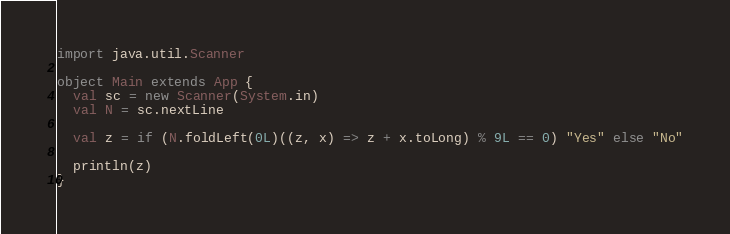Convert code to text. <code><loc_0><loc_0><loc_500><loc_500><_Scala_>import java.util.Scanner

object Main extends App {
  val sc = new Scanner(System.in)
  val N = sc.nextLine

  val z = if (N.foldLeft(0L)((z, x) => z + x.toLong) % 9L == 0) "Yes" else "No"

  println(z)
}
</code> 